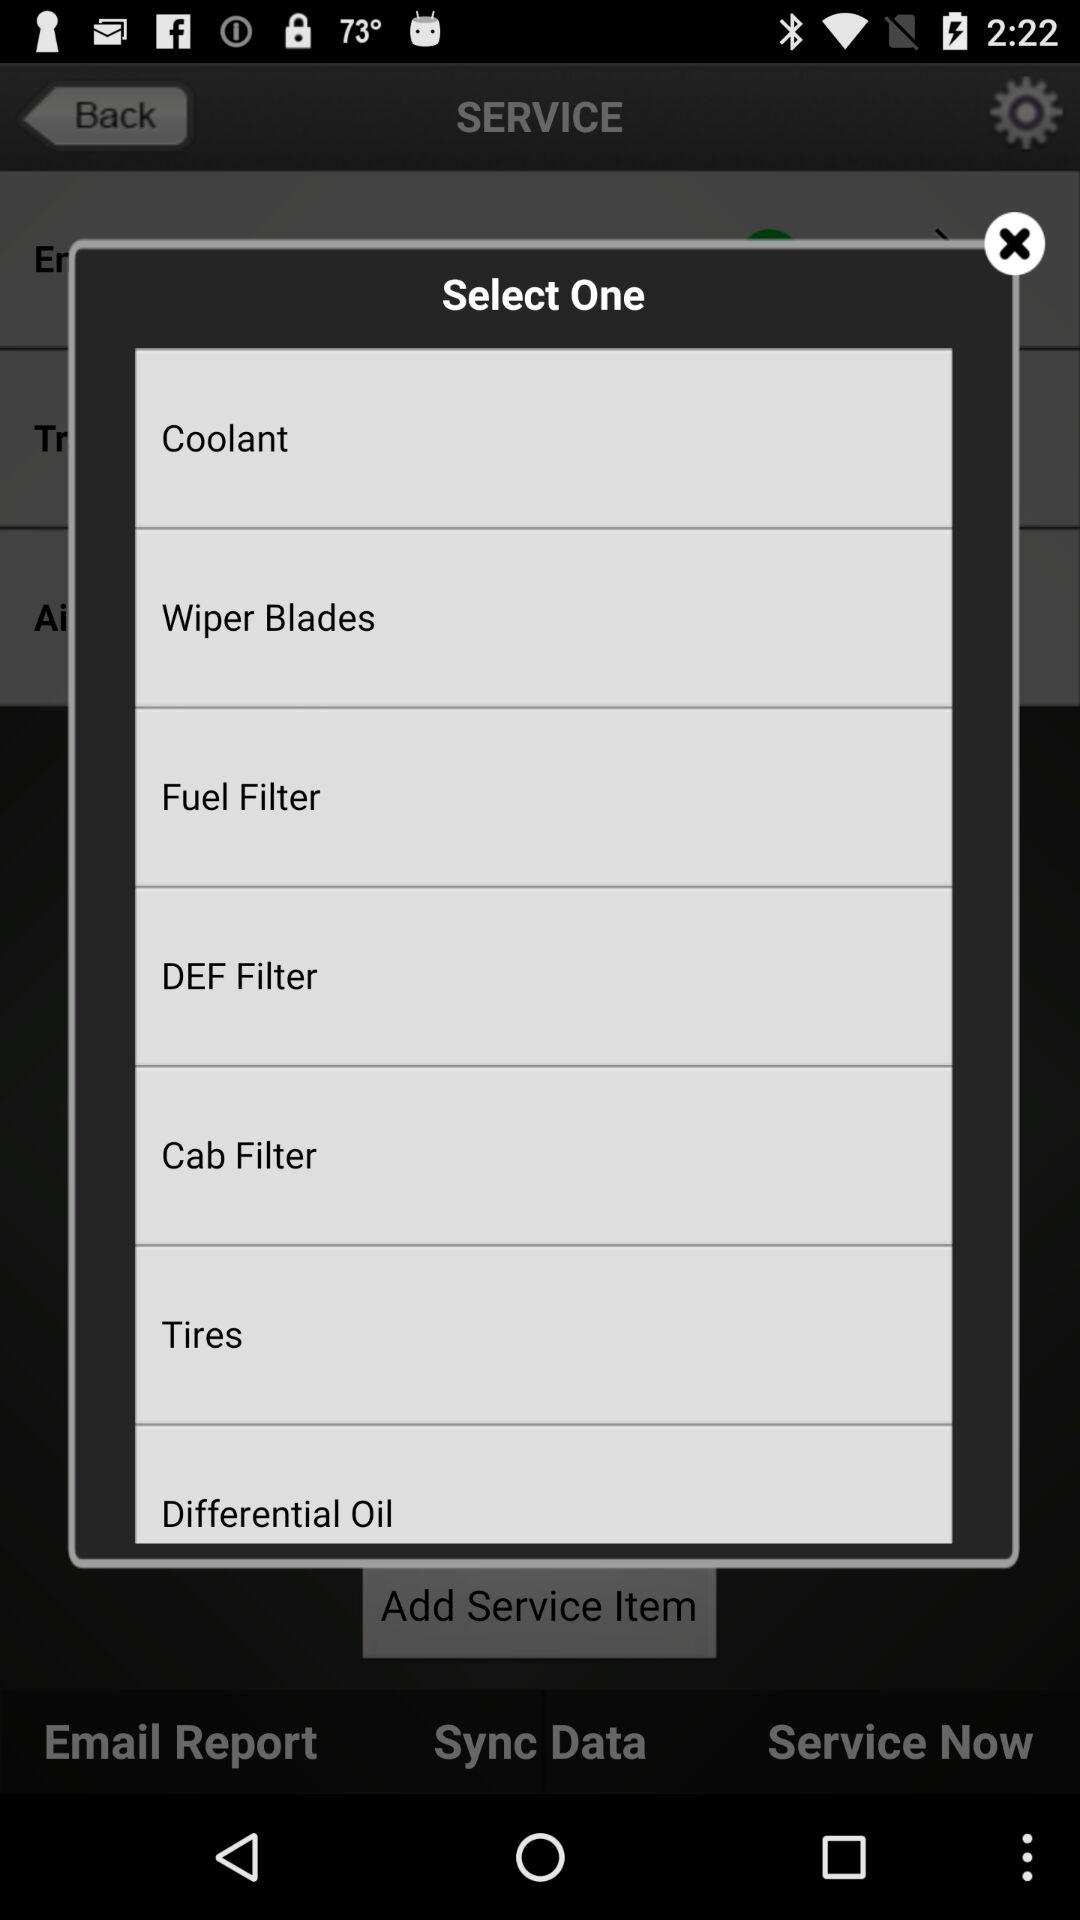Which tab is selected?
When the provided information is insufficient, respond with <no answer>. <no answer> 